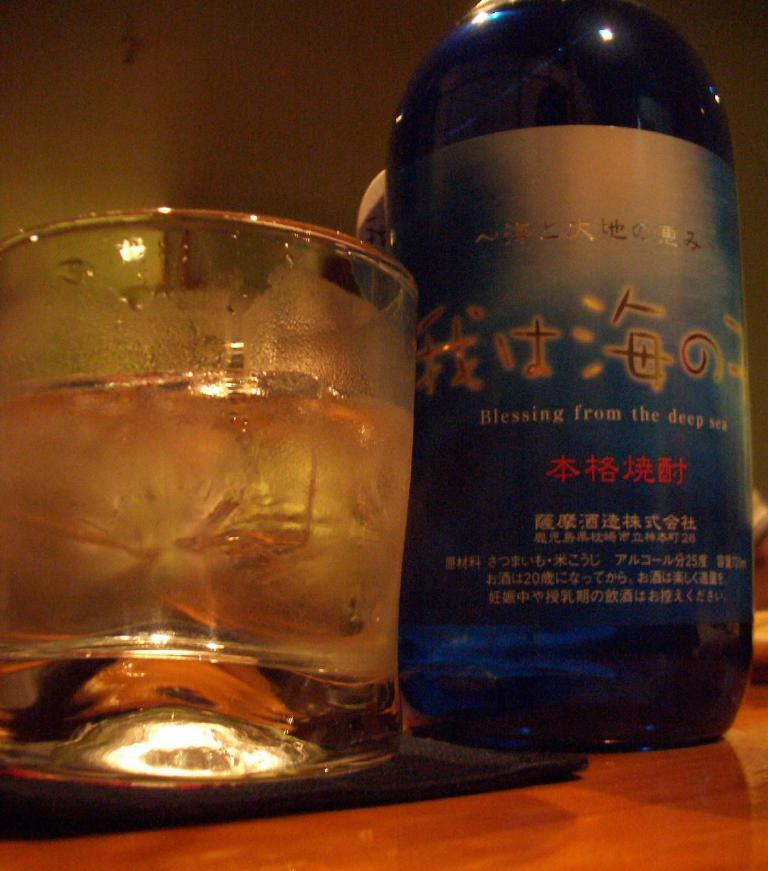Provide a one-sentence caption for the provided image. A short glass next to a blue bottle with Asian text offering blessings from the deep sea. 